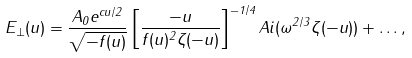Convert formula to latex. <formula><loc_0><loc_0><loc_500><loc_500>E _ { \perp } ( u ) = \frac { A _ { 0 } e ^ { c u / 2 } } { \sqrt { - f ( u ) } } \left [ \frac { - u } { f ( u ) ^ { 2 } \zeta ( - u ) } \right ] ^ { - 1 / 4 } A i ( \omega ^ { 2 / 3 } \zeta ( - u ) ) + \dots ,</formula> 